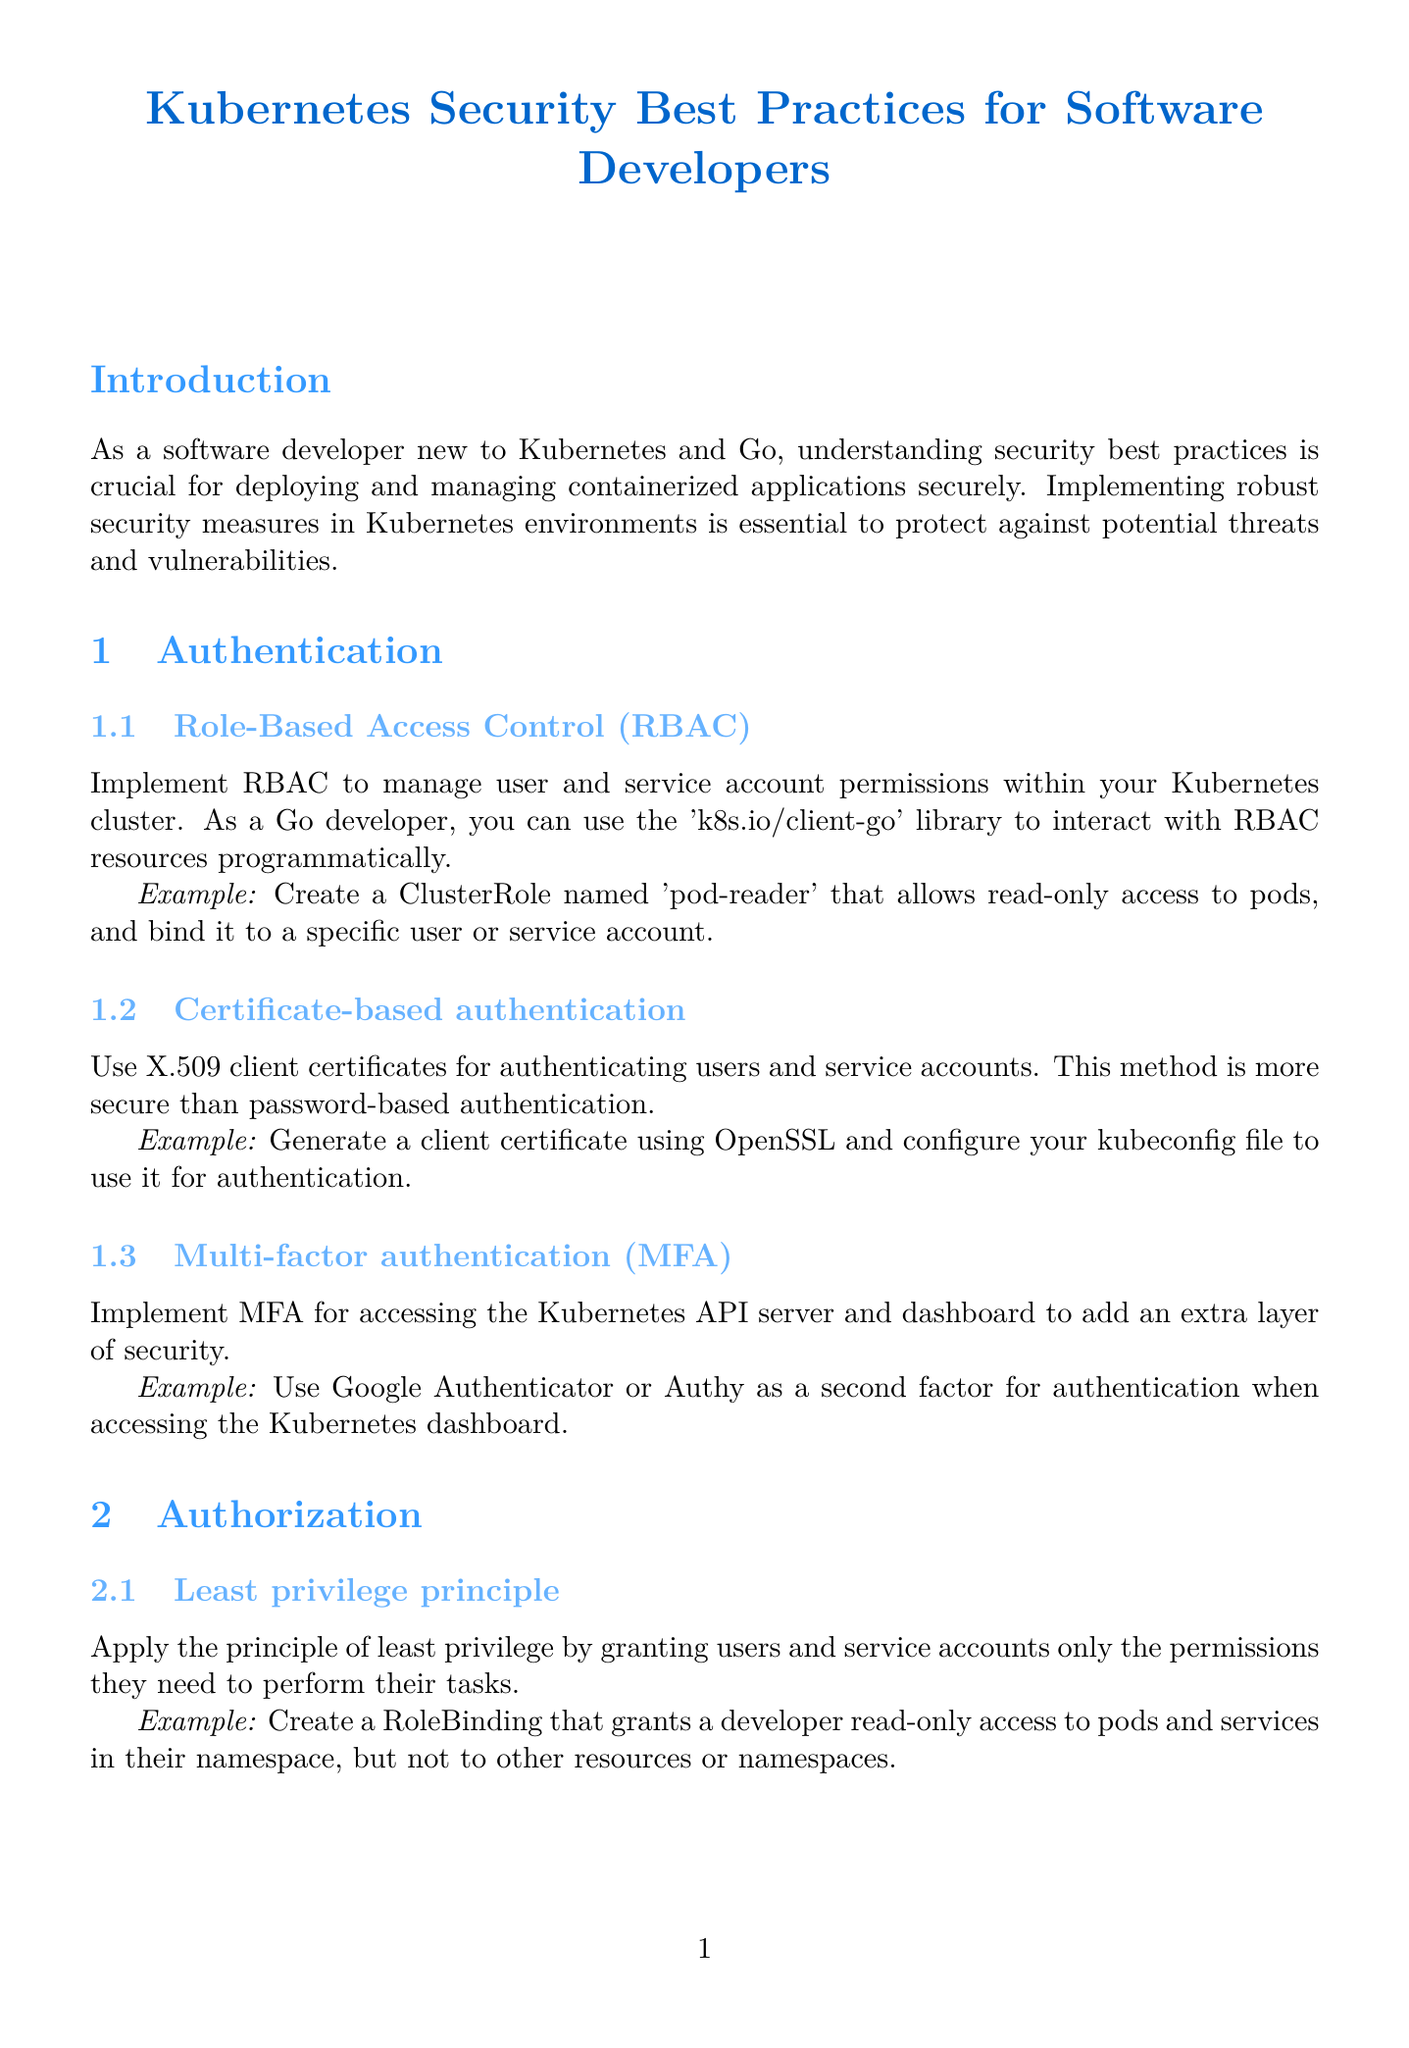What is the title of the report? The title is explicitly mentioned at the beginning of the document.
Answer: Kubernetes Security Best Practices for Software Developers How many subtopics are listed under Authentication? The content outlines each section with subtopics, totaling three under Authentication.
Answer: 3 What is the example provided for Multi-factor authentication? The document includes specific examples for each subtopic, including one for Multi-factor authentication.
Answer: Use Google Authenticator or Authy as a second factor for authentication when accessing the Kubernetes dashboard What principle should be applied for authorization? The report states a key principle regarding permissions for users and service accounts.
Answer: Least privilege principle What is recommended to do for network traffic policy? The section discusses the approach to managing network traffic within the cluster, specifically the default stance recommended.
Answer: Default deny policy How can container images be validated for integrity? The document specifies an approach for ensuring the authenticity of container images.
Answer: Use Docker Content Trust (DCT) What is the first item listed in the Resources section? The document lists several resources; the first is identified by its title.
Answer: Kubernetes Documentation - Security What is suggested as a minimal base image? The report refers to certain types of base images, highlighting minimal options.
Answer: Alpine Linux or distroless images 